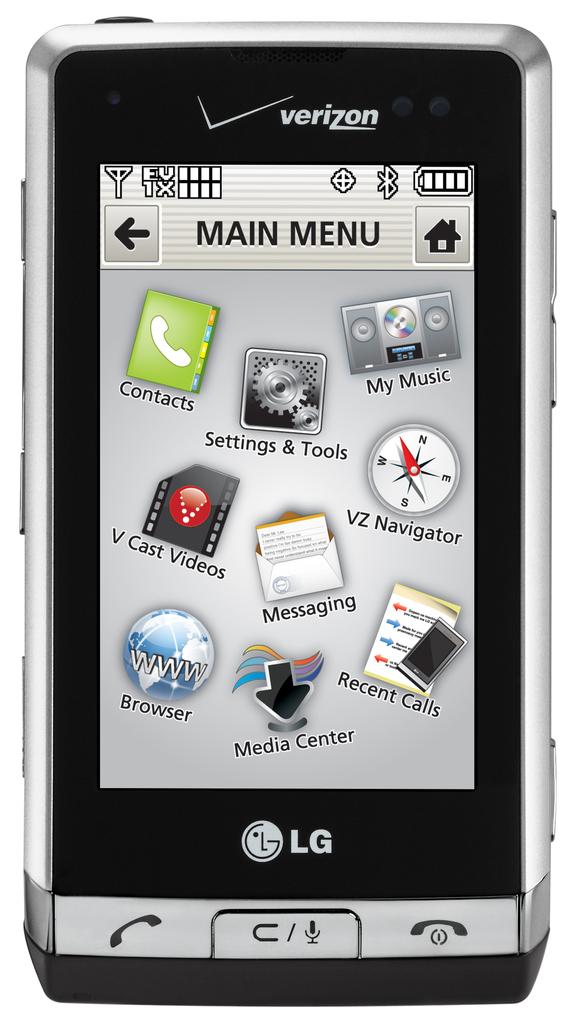What phone brand is this?
Offer a very short reply. Lg. Does this phone have a media center?
Provide a short and direct response. Yes. 